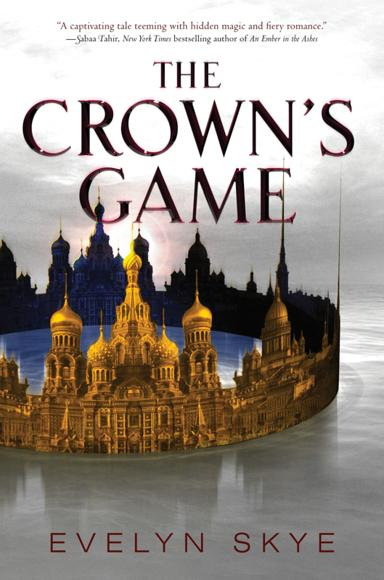What details can you provide about the author Evelyn Skye and her background in writing this novel? Evelyn Skye is an author known for weaving compelling tales with a touch of magic. A lover of Russian history and a former professional dancer, Skye infuses 'The Crown’s Game' with her passion for Russia’s rich cultural tapestry and her insights into the intricate maneuvers akin to a dance, mirroring the novel's central magical duels. 